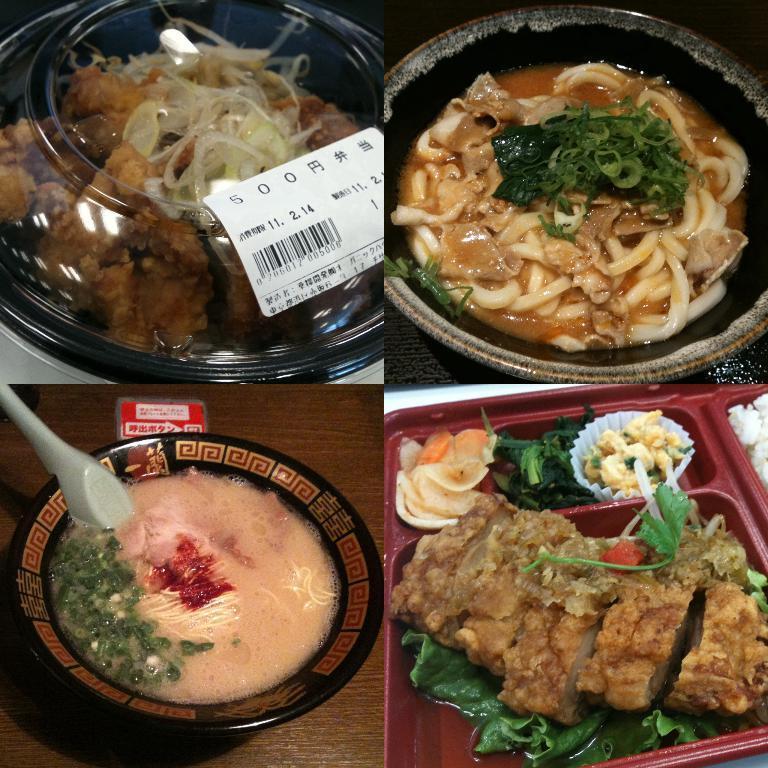In one or two sentences, can you explain what this image depicts? This image contains collage of photos. In the photos there are plates having food in it. Left bottom there is a plate having some food and a spoon it. Left top there is a plate having food which is covered with a lid. On the lid there is a label attached to it. 